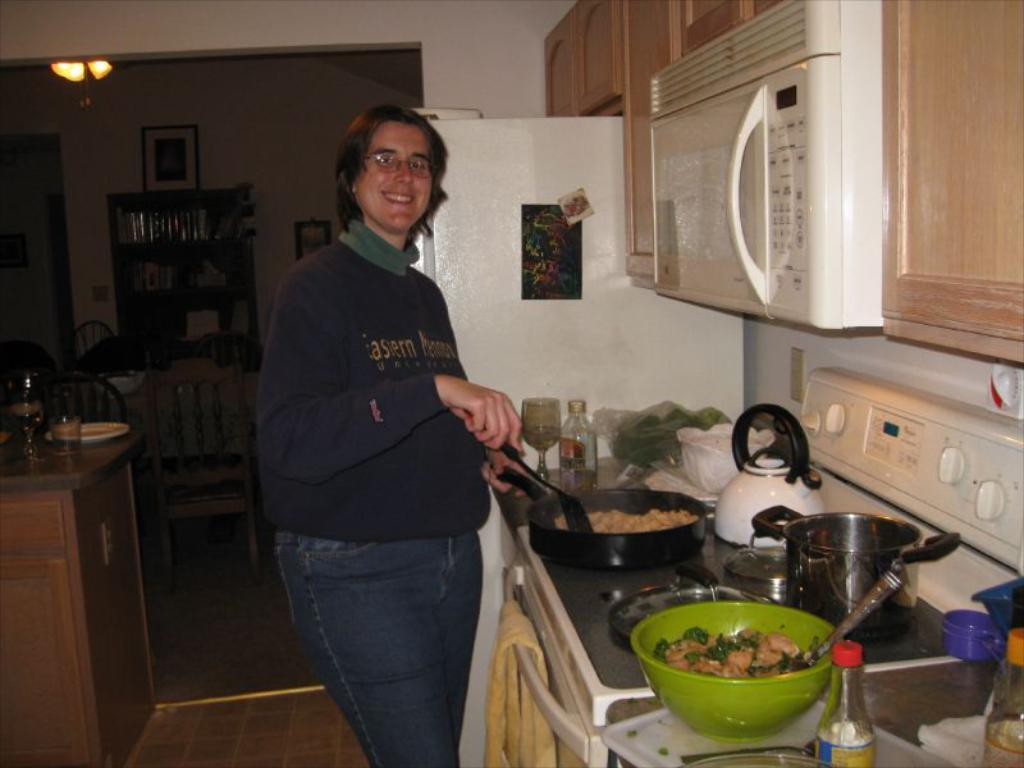Provide a one-sentence caption for the provided image. A person cooking in the kitchen with a sweatshirt on has the word "Eastern" on it. 